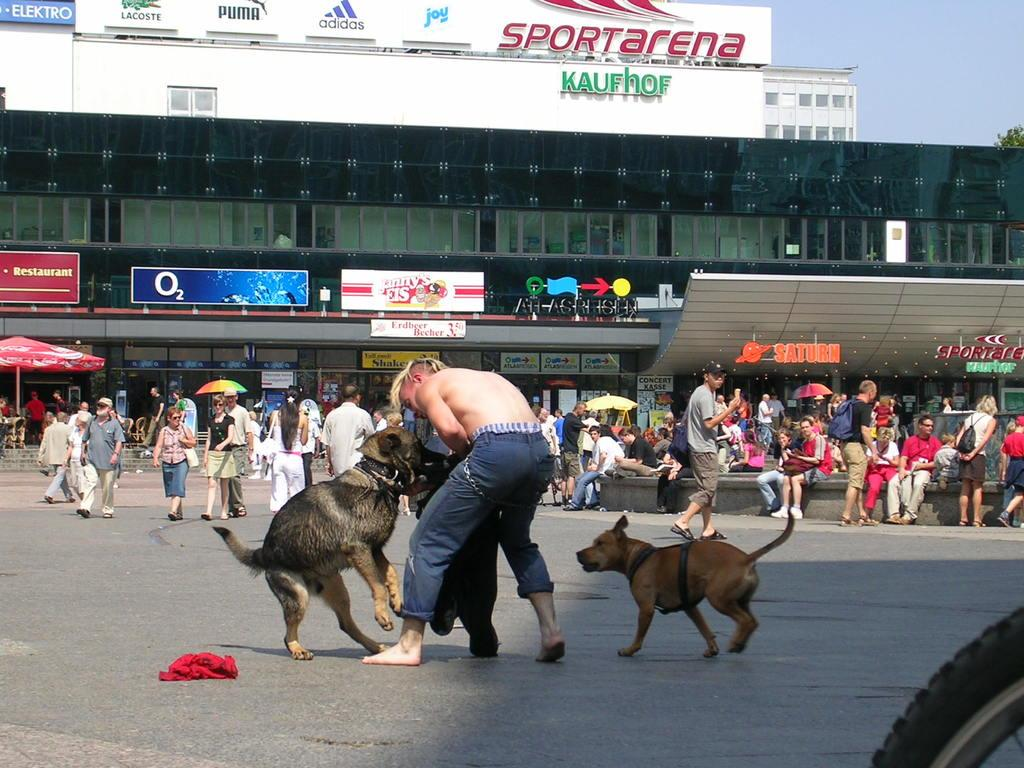What type of structure is visible in the image? There is a building in the image. What is hanging or attached to the building? There is a banner and a poster in the image. What is happening on the road in the image? There are people walking on the road in the image. What animals can be seen in the front of the image? There are two dogs in the front of the image. What type of baseball is being played by the dogs in the image? There is no baseball or any sports activity depicted in the image; it features two dogs in the front. What musical instrument is being played by the people walking on the road in the image? There is no musical instrument or any indication of music being played in the image. 